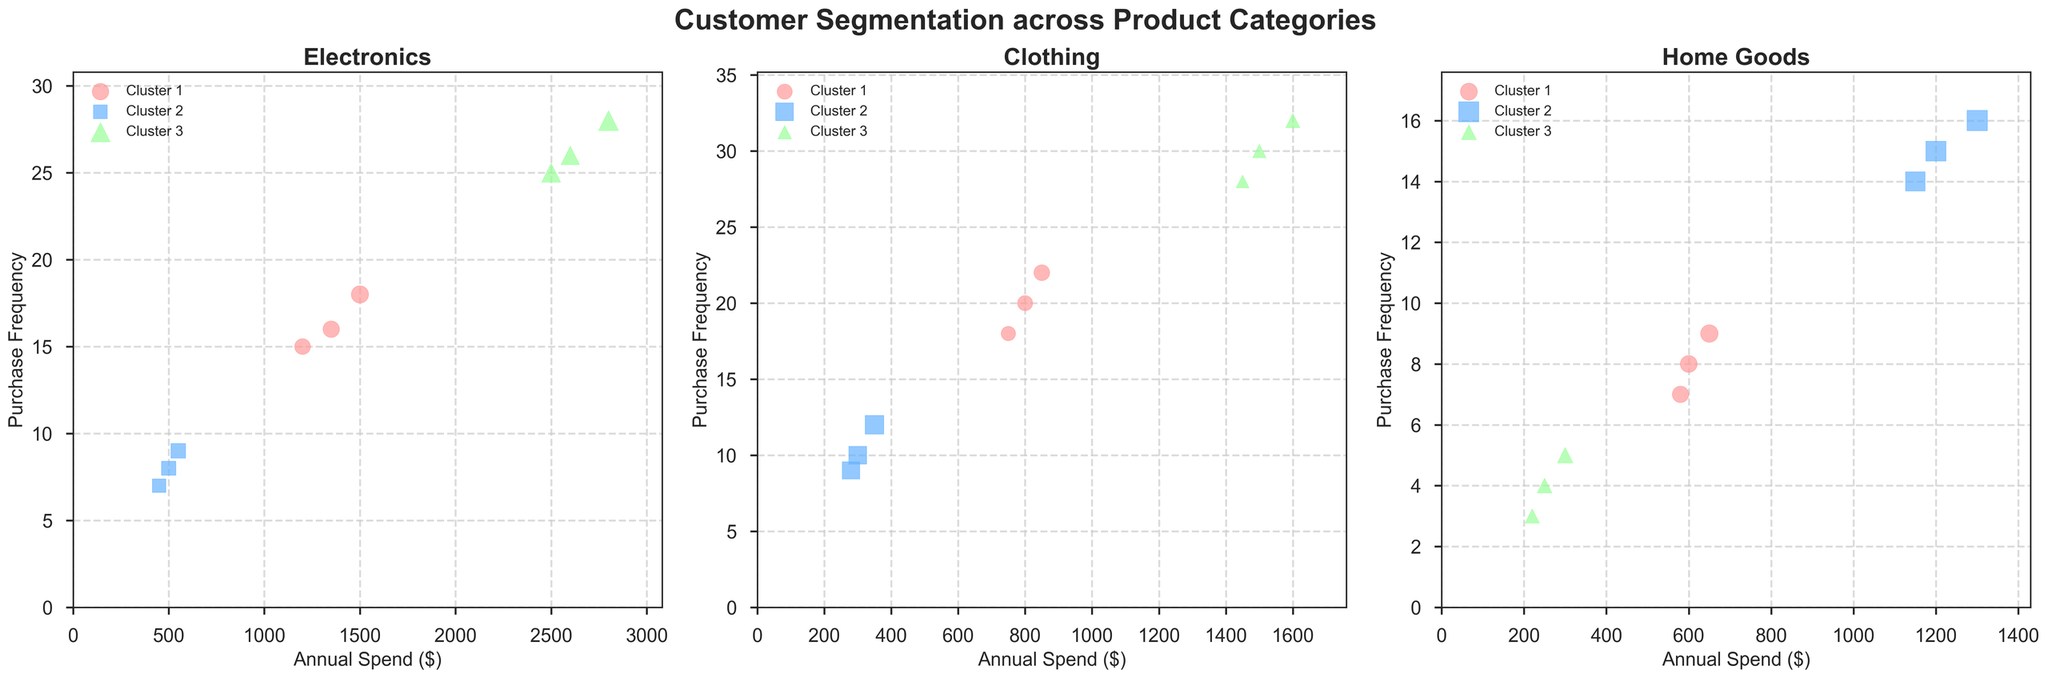What is the title of the plot? The title of the plot is located at the top of the figure. It reads "Customer Segmentation across Product Categories"
Answer: Customer Segmentation across Product Categories Which cluster has the highest annual spend in the Electronics category? In the subplot for Electronics, look for the cluster with the data points that have the highest x-values. Cluster 3 has data points with the highest annual spend values of 2500, 2800, and 2600 dollars.
Answer: Cluster 3 How are the markers differentiated between clusters? Different clusters within each category use different marker shapes. Cluster 1 uses circles, Cluster 2 uses squares, and Cluster 3 uses triangles.
Answer: By different marker shapes What is the average purchase frequency for Cluster 2 in the Clothing category? In the subplot for Clothing, find the data points for Cluster 2. Their purchase frequencies are 10, 12, and 9. Average these values: (10 + 12 + 9) / 3 = 10.33.
Answer: 10.33 Which category shows the most diverse range of annual spend across clusters? Compare the ranges of annual spend visually across the three subplots. Electronics shows the largest variation, with values from around 450 to 2800 dollars.
Answer: Electronics What is the relationship between annual spend and purchase frequency in Cluster 3 of the Home Goods category? In the Home Goods subplot, observe Cluster 3 data points. They have low annual spend (250, 300, and 220 dollars) and low purchase frequency (4, 5, and 3). This suggests a positive relationship where low spend corresponds to low frequency.
Answer: Positive relationship where low spend corresponds to low frequency Which cluster in the Home Goods category has the oldest average customer age? In the Home Goods subplot, observe the ages of customers in each cluster. Cluster 2 contains ages 55, 58, and 52, which are higher than the other clusters. Thus, Cluster 2 has the oldest average age.
Answer: Cluster 2 Compare the annual spend for Clusters 1 across all categories. Which category has the highest average annual spend for Cluster 1? Calculate the average annual spend for Cluster 1 in each category: Electronics (1200, 1500, 1350), Clothing (800, 750, 850), Home Goods (600, 650, 580). Their averages are: Electronics: 1350, Clothing: 800, Home Goods: 610. Electronics has the highest average of 1350.
Answer: Electronics How does purchase frequency vary with customer age in the Clothing category? In the Clothing subplot, look at the variation of purchase frequency with customer age. Generally, clusters with younger customers (Cluster 3: ages around 25-28) have higher purchase frequencies, while clusters with older customers (Cluster 2: ages around 42-48) have lower frequencies.
Answer: Younger customers have higher purchase frequency, older customers have lower frequency What does the size of the markers represent in the subplots? The size of the markers represents the customer age. Larger markers indicate older customers and smaller markers indicate younger customers.
Answer: Customer age 